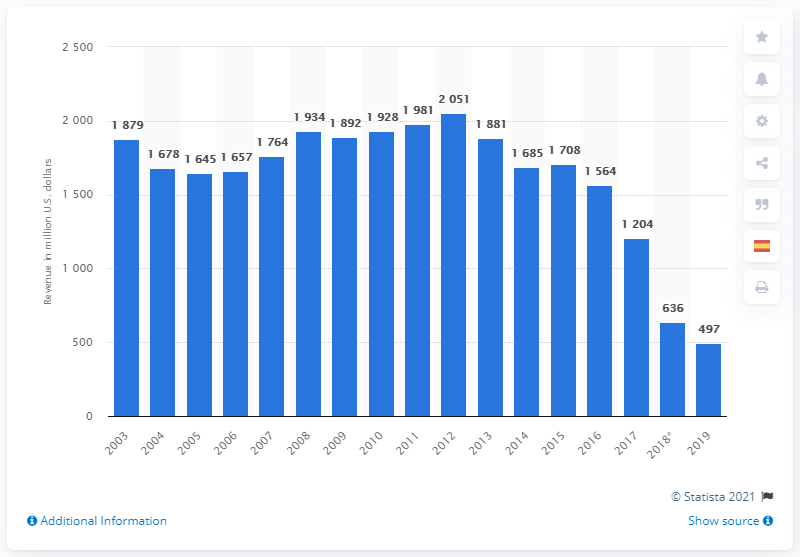Highlight a few significant elements in this photo. In 2019, the revenue generated by Viagra was approximately $497 million. 